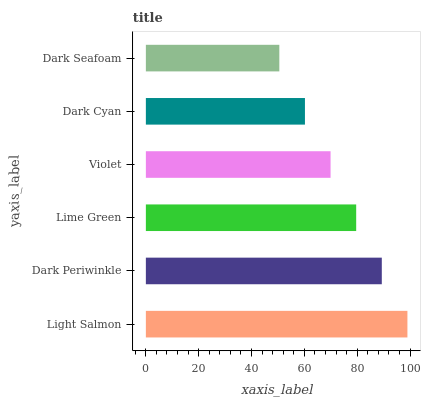Is Dark Seafoam the minimum?
Answer yes or no. Yes. Is Light Salmon the maximum?
Answer yes or no. Yes. Is Dark Periwinkle the minimum?
Answer yes or no. No. Is Dark Periwinkle the maximum?
Answer yes or no. No. Is Light Salmon greater than Dark Periwinkle?
Answer yes or no. Yes. Is Dark Periwinkle less than Light Salmon?
Answer yes or no. Yes. Is Dark Periwinkle greater than Light Salmon?
Answer yes or no. No. Is Light Salmon less than Dark Periwinkle?
Answer yes or no. No. Is Lime Green the high median?
Answer yes or no. Yes. Is Violet the low median?
Answer yes or no. Yes. Is Light Salmon the high median?
Answer yes or no. No. Is Light Salmon the low median?
Answer yes or no. No. 